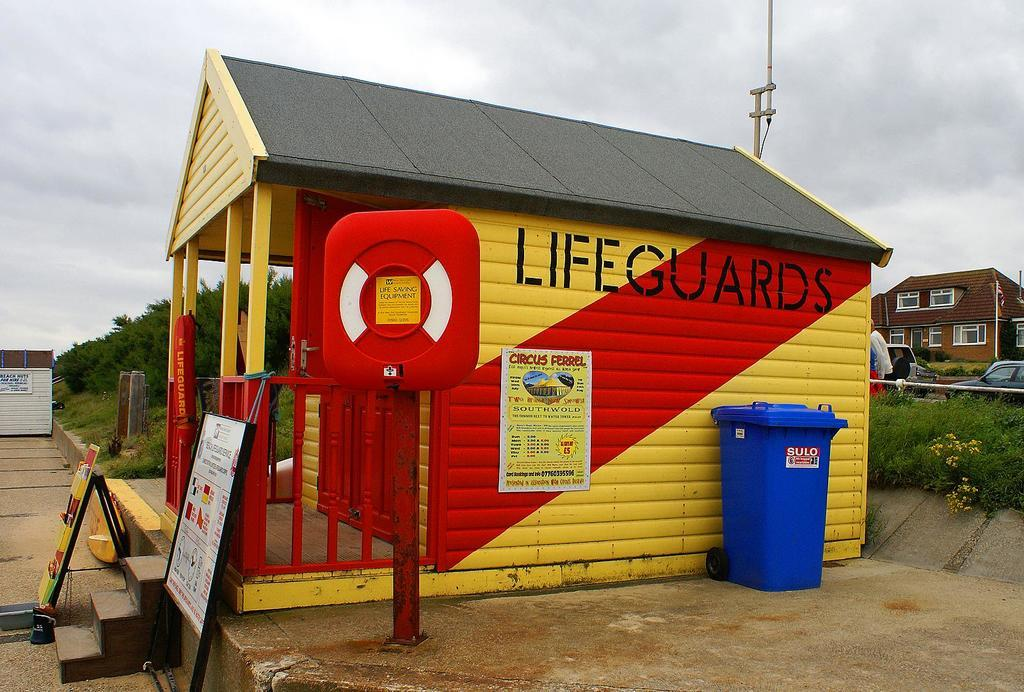<image>
Offer a succinct explanation of the picture presented. A yellow and red outdoor shed for Lifeguards 